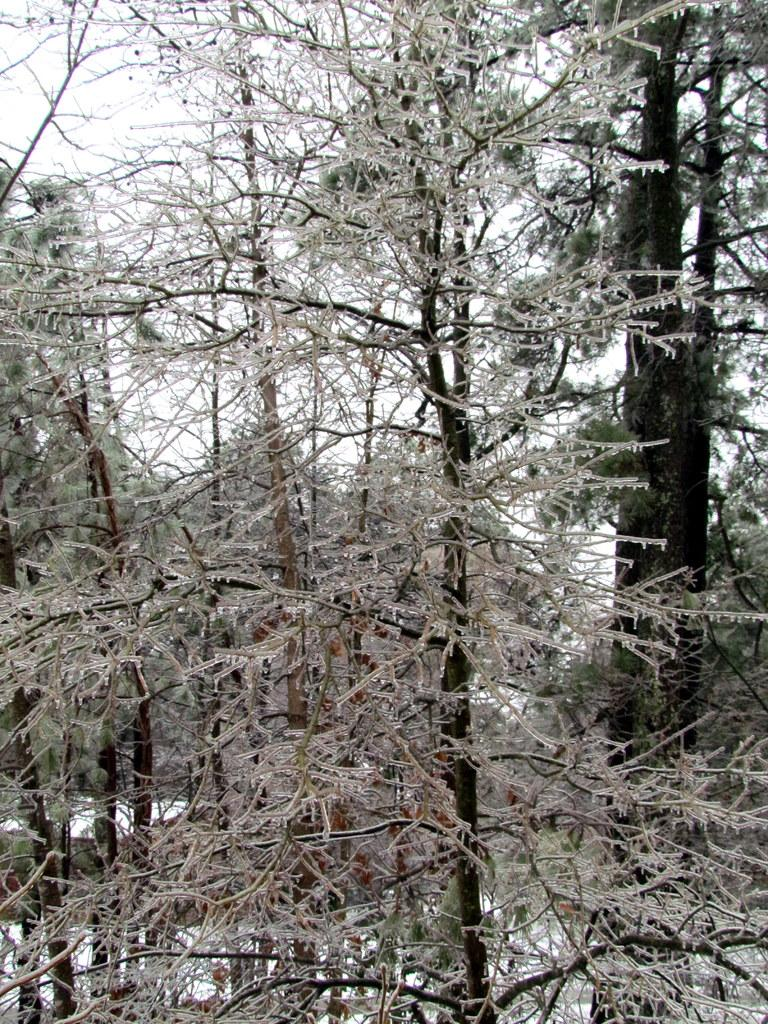What type of vegetation can be seen in the image? There are trees in the image. What part of the natural environment is visible in the image? The sky is visible in the background of the image. Where is the stage located in the image? There is no stage present in the image. What type of country is depicted in the image? The image does not depict a specific country; it only shows trees and the sky. 